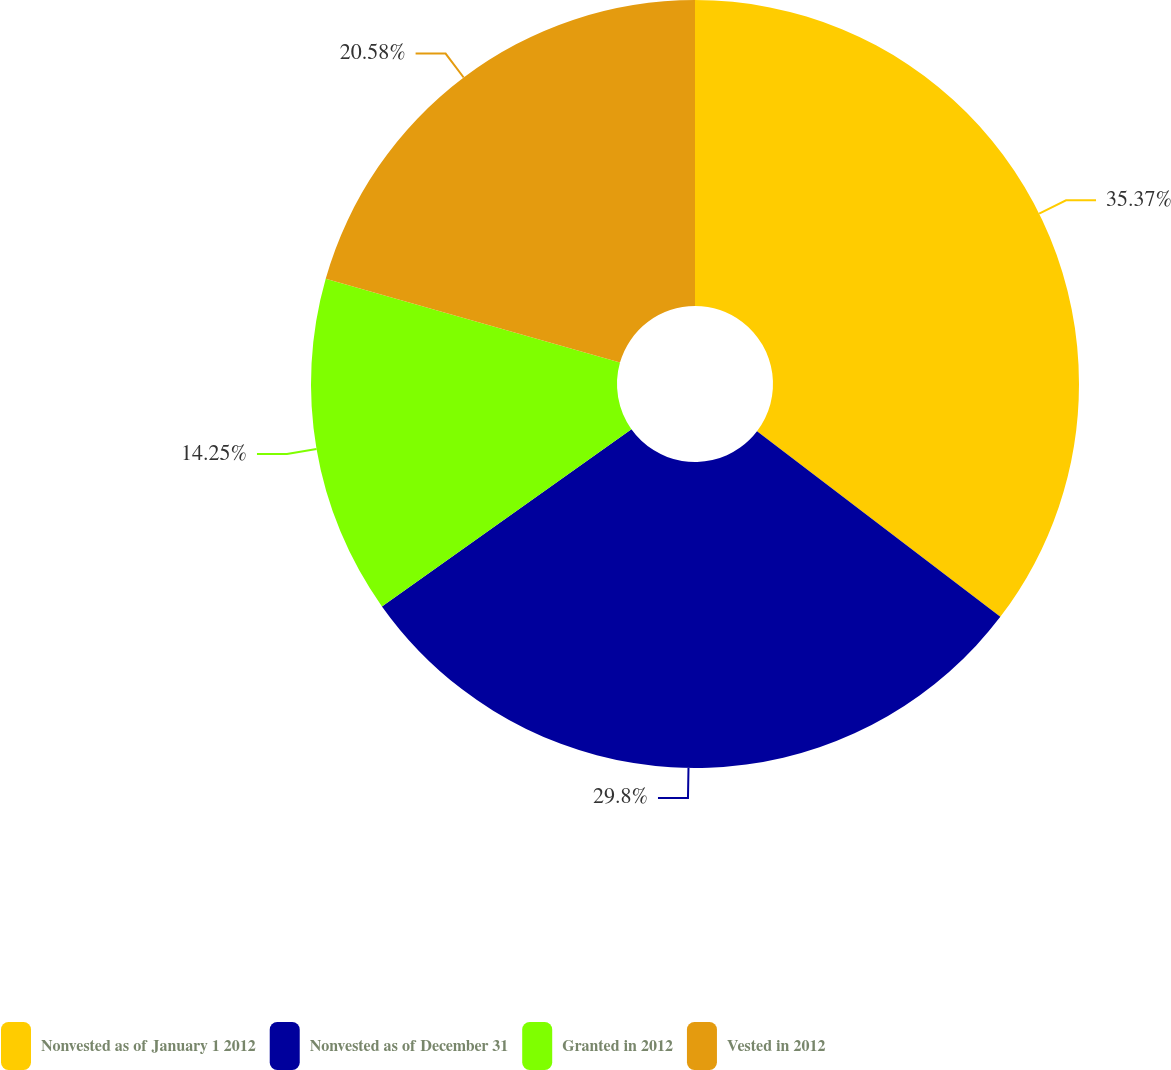Convert chart to OTSL. <chart><loc_0><loc_0><loc_500><loc_500><pie_chart><fcel>Nonvested as of January 1 2012<fcel>Nonvested as of December 31<fcel>Granted in 2012<fcel>Vested in 2012<nl><fcel>35.37%<fcel>29.8%<fcel>14.25%<fcel>20.58%<nl></chart> 